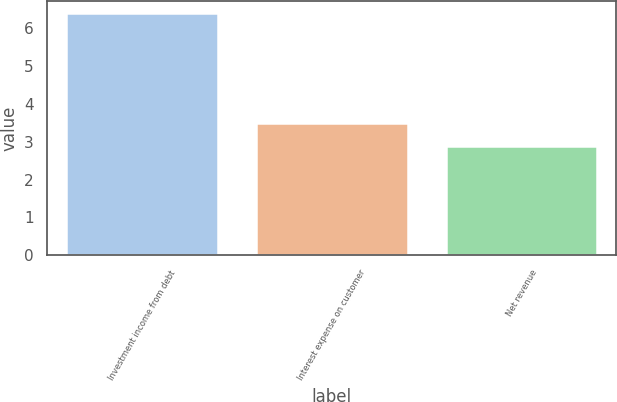Convert chart to OTSL. <chart><loc_0><loc_0><loc_500><loc_500><bar_chart><fcel>Investment income from debt<fcel>Interest expense on customer<fcel>Net revenue<nl><fcel>6.4<fcel>3.5<fcel>2.9<nl></chart> 